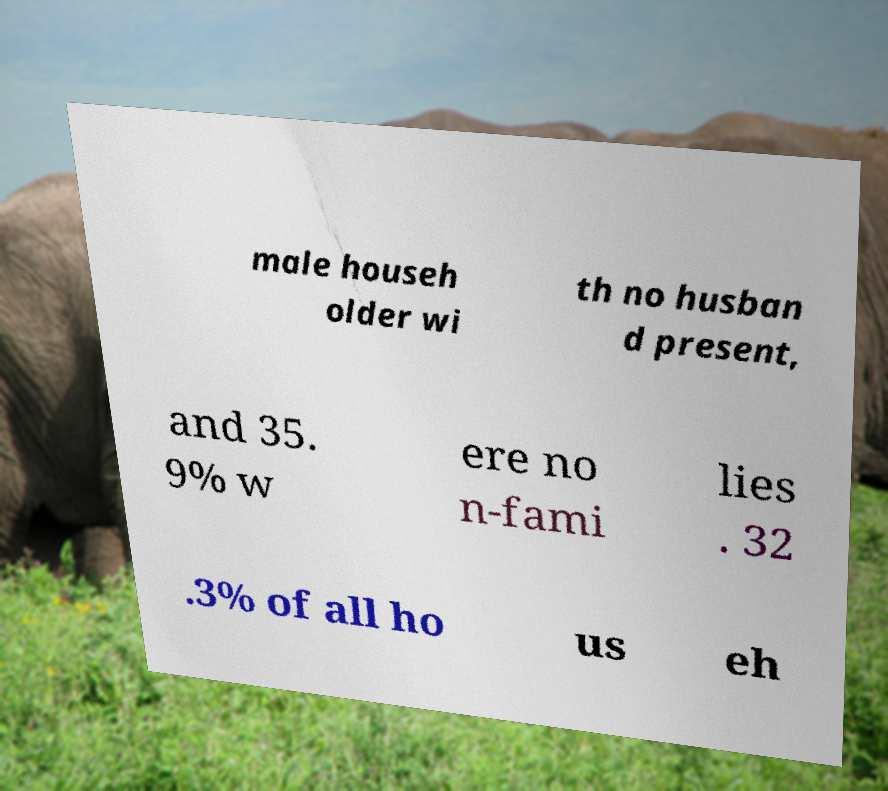Please identify and transcribe the text found in this image. male househ older wi th no husban d present, and 35. 9% w ere no n-fami lies . 32 .3% of all ho us eh 